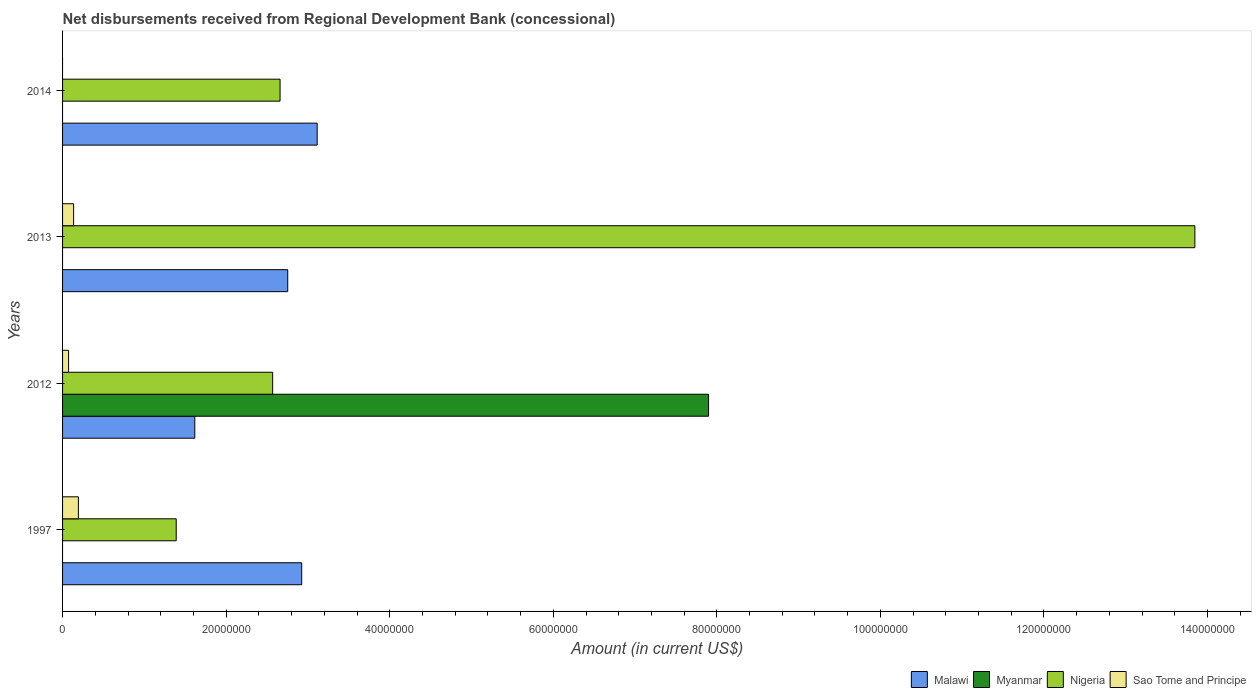How many different coloured bars are there?
Your answer should be very brief. 4. Are the number of bars per tick equal to the number of legend labels?
Provide a short and direct response. No. What is the amount of disbursements received from Regional Development Bank in Nigeria in 2012?
Give a very brief answer. 2.57e+07. Across all years, what is the maximum amount of disbursements received from Regional Development Bank in Sao Tome and Principe?
Offer a very short reply. 1.93e+06. In which year was the amount of disbursements received from Regional Development Bank in Malawi maximum?
Offer a very short reply. 2014. What is the total amount of disbursements received from Regional Development Bank in Sao Tome and Principe in the graph?
Offer a terse response. 4.02e+06. What is the difference between the amount of disbursements received from Regional Development Bank in Malawi in 2013 and that in 2014?
Your answer should be very brief. -3.60e+06. What is the difference between the amount of disbursements received from Regional Development Bank in Sao Tome and Principe in 2014 and the amount of disbursements received from Regional Development Bank in Malawi in 2012?
Keep it short and to the point. -1.62e+07. What is the average amount of disbursements received from Regional Development Bank in Myanmar per year?
Keep it short and to the point. 1.97e+07. In the year 2013, what is the difference between the amount of disbursements received from Regional Development Bank in Sao Tome and Principe and amount of disbursements received from Regional Development Bank in Malawi?
Provide a succinct answer. -2.62e+07. In how many years, is the amount of disbursements received from Regional Development Bank in Sao Tome and Principe greater than 108000000 US$?
Ensure brevity in your answer.  0. What is the ratio of the amount of disbursements received from Regional Development Bank in Malawi in 2013 to that in 2014?
Ensure brevity in your answer.  0.88. What is the difference between the highest and the second highest amount of disbursements received from Regional Development Bank in Nigeria?
Make the answer very short. 1.12e+08. What is the difference between the highest and the lowest amount of disbursements received from Regional Development Bank in Nigeria?
Your answer should be compact. 1.25e+08. In how many years, is the amount of disbursements received from Regional Development Bank in Sao Tome and Principe greater than the average amount of disbursements received from Regional Development Bank in Sao Tome and Principe taken over all years?
Offer a terse response. 2. Is the sum of the amount of disbursements received from Regional Development Bank in Malawi in 2012 and 2013 greater than the maximum amount of disbursements received from Regional Development Bank in Nigeria across all years?
Your answer should be compact. No. Is it the case that in every year, the sum of the amount of disbursements received from Regional Development Bank in Malawi and amount of disbursements received from Regional Development Bank in Nigeria is greater than the amount of disbursements received from Regional Development Bank in Sao Tome and Principe?
Offer a very short reply. Yes. How many bars are there?
Give a very brief answer. 12. How many years are there in the graph?
Provide a succinct answer. 4. Are the values on the major ticks of X-axis written in scientific E-notation?
Provide a short and direct response. No. Does the graph contain any zero values?
Provide a succinct answer. Yes. Where does the legend appear in the graph?
Offer a terse response. Bottom right. How are the legend labels stacked?
Make the answer very short. Horizontal. What is the title of the graph?
Ensure brevity in your answer.  Net disbursements received from Regional Development Bank (concessional). What is the Amount (in current US$) of Malawi in 1997?
Offer a very short reply. 2.92e+07. What is the Amount (in current US$) of Myanmar in 1997?
Make the answer very short. 0. What is the Amount (in current US$) in Nigeria in 1997?
Your response must be concise. 1.39e+07. What is the Amount (in current US$) in Sao Tome and Principe in 1997?
Keep it short and to the point. 1.93e+06. What is the Amount (in current US$) of Malawi in 2012?
Your answer should be compact. 1.62e+07. What is the Amount (in current US$) in Myanmar in 2012?
Your answer should be compact. 7.90e+07. What is the Amount (in current US$) in Nigeria in 2012?
Offer a terse response. 2.57e+07. What is the Amount (in current US$) in Sao Tome and Principe in 2012?
Provide a short and direct response. 7.36e+05. What is the Amount (in current US$) of Malawi in 2013?
Offer a very short reply. 2.75e+07. What is the Amount (in current US$) of Myanmar in 2013?
Provide a short and direct response. 0. What is the Amount (in current US$) in Nigeria in 2013?
Your answer should be compact. 1.38e+08. What is the Amount (in current US$) in Sao Tome and Principe in 2013?
Keep it short and to the point. 1.35e+06. What is the Amount (in current US$) of Malawi in 2014?
Keep it short and to the point. 3.11e+07. What is the Amount (in current US$) in Nigeria in 2014?
Offer a very short reply. 2.66e+07. What is the Amount (in current US$) of Sao Tome and Principe in 2014?
Your response must be concise. 0. Across all years, what is the maximum Amount (in current US$) of Malawi?
Your answer should be compact. 3.11e+07. Across all years, what is the maximum Amount (in current US$) in Myanmar?
Your answer should be compact. 7.90e+07. Across all years, what is the maximum Amount (in current US$) in Nigeria?
Your answer should be compact. 1.38e+08. Across all years, what is the maximum Amount (in current US$) of Sao Tome and Principe?
Give a very brief answer. 1.93e+06. Across all years, what is the minimum Amount (in current US$) of Malawi?
Keep it short and to the point. 1.62e+07. Across all years, what is the minimum Amount (in current US$) of Nigeria?
Offer a terse response. 1.39e+07. Across all years, what is the minimum Amount (in current US$) in Sao Tome and Principe?
Your answer should be very brief. 0. What is the total Amount (in current US$) of Malawi in the graph?
Offer a terse response. 1.04e+08. What is the total Amount (in current US$) of Myanmar in the graph?
Ensure brevity in your answer.  7.90e+07. What is the total Amount (in current US$) in Nigeria in the graph?
Keep it short and to the point. 2.05e+08. What is the total Amount (in current US$) of Sao Tome and Principe in the graph?
Your answer should be compact. 4.02e+06. What is the difference between the Amount (in current US$) of Malawi in 1997 and that in 2012?
Offer a terse response. 1.31e+07. What is the difference between the Amount (in current US$) in Nigeria in 1997 and that in 2012?
Make the answer very short. -1.18e+07. What is the difference between the Amount (in current US$) of Sao Tome and Principe in 1997 and that in 2012?
Provide a short and direct response. 1.20e+06. What is the difference between the Amount (in current US$) of Malawi in 1997 and that in 2013?
Offer a terse response. 1.71e+06. What is the difference between the Amount (in current US$) of Nigeria in 1997 and that in 2013?
Offer a terse response. -1.25e+08. What is the difference between the Amount (in current US$) in Sao Tome and Principe in 1997 and that in 2013?
Give a very brief answer. 5.84e+05. What is the difference between the Amount (in current US$) of Malawi in 1997 and that in 2014?
Give a very brief answer. -1.89e+06. What is the difference between the Amount (in current US$) in Nigeria in 1997 and that in 2014?
Offer a terse response. -1.27e+07. What is the difference between the Amount (in current US$) of Malawi in 2012 and that in 2013?
Provide a short and direct response. -1.14e+07. What is the difference between the Amount (in current US$) in Nigeria in 2012 and that in 2013?
Your answer should be very brief. -1.13e+08. What is the difference between the Amount (in current US$) of Sao Tome and Principe in 2012 and that in 2013?
Give a very brief answer. -6.14e+05. What is the difference between the Amount (in current US$) of Malawi in 2012 and that in 2014?
Offer a very short reply. -1.50e+07. What is the difference between the Amount (in current US$) of Nigeria in 2012 and that in 2014?
Give a very brief answer. -9.05e+05. What is the difference between the Amount (in current US$) of Malawi in 2013 and that in 2014?
Offer a very short reply. -3.60e+06. What is the difference between the Amount (in current US$) in Nigeria in 2013 and that in 2014?
Your answer should be very brief. 1.12e+08. What is the difference between the Amount (in current US$) of Malawi in 1997 and the Amount (in current US$) of Myanmar in 2012?
Keep it short and to the point. -4.97e+07. What is the difference between the Amount (in current US$) of Malawi in 1997 and the Amount (in current US$) of Nigeria in 2012?
Keep it short and to the point. 3.55e+06. What is the difference between the Amount (in current US$) of Malawi in 1997 and the Amount (in current US$) of Sao Tome and Principe in 2012?
Make the answer very short. 2.85e+07. What is the difference between the Amount (in current US$) of Nigeria in 1997 and the Amount (in current US$) of Sao Tome and Principe in 2012?
Provide a succinct answer. 1.32e+07. What is the difference between the Amount (in current US$) of Malawi in 1997 and the Amount (in current US$) of Nigeria in 2013?
Give a very brief answer. -1.09e+08. What is the difference between the Amount (in current US$) of Malawi in 1997 and the Amount (in current US$) of Sao Tome and Principe in 2013?
Your answer should be very brief. 2.79e+07. What is the difference between the Amount (in current US$) of Nigeria in 1997 and the Amount (in current US$) of Sao Tome and Principe in 2013?
Ensure brevity in your answer.  1.25e+07. What is the difference between the Amount (in current US$) of Malawi in 1997 and the Amount (in current US$) of Nigeria in 2014?
Your answer should be compact. 2.65e+06. What is the difference between the Amount (in current US$) in Malawi in 2012 and the Amount (in current US$) in Nigeria in 2013?
Your answer should be compact. -1.22e+08. What is the difference between the Amount (in current US$) of Malawi in 2012 and the Amount (in current US$) of Sao Tome and Principe in 2013?
Your answer should be very brief. 1.48e+07. What is the difference between the Amount (in current US$) in Myanmar in 2012 and the Amount (in current US$) in Nigeria in 2013?
Give a very brief answer. -5.95e+07. What is the difference between the Amount (in current US$) of Myanmar in 2012 and the Amount (in current US$) of Sao Tome and Principe in 2013?
Your response must be concise. 7.76e+07. What is the difference between the Amount (in current US$) of Nigeria in 2012 and the Amount (in current US$) of Sao Tome and Principe in 2013?
Keep it short and to the point. 2.43e+07. What is the difference between the Amount (in current US$) of Malawi in 2012 and the Amount (in current US$) of Nigeria in 2014?
Ensure brevity in your answer.  -1.04e+07. What is the difference between the Amount (in current US$) of Myanmar in 2012 and the Amount (in current US$) of Nigeria in 2014?
Keep it short and to the point. 5.24e+07. What is the difference between the Amount (in current US$) of Malawi in 2013 and the Amount (in current US$) of Nigeria in 2014?
Offer a terse response. 9.39e+05. What is the average Amount (in current US$) of Malawi per year?
Make the answer very short. 2.60e+07. What is the average Amount (in current US$) of Myanmar per year?
Your answer should be very brief. 1.97e+07. What is the average Amount (in current US$) in Nigeria per year?
Offer a very short reply. 5.12e+07. What is the average Amount (in current US$) of Sao Tome and Principe per year?
Provide a short and direct response. 1.00e+06. In the year 1997, what is the difference between the Amount (in current US$) in Malawi and Amount (in current US$) in Nigeria?
Make the answer very short. 1.53e+07. In the year 1997, what is the difference between the Amount (in current US$) of Malawi and Amount (in current US$) of Sao Tome and Principe?
Your response must be concise. 2.73e+07. In the year 1997, what is the difference between the Amount (in current US$) of Nigeria and Amount (in current US$) of Sao Tome and Principe?
Offer a terse response. 1.20e+07. In the year 2012, what is the difference between the Amount (in current US$) in Malawi and Amount (in current US$) in Myanmar?
Keep it short and to the point. -6.28e+07. In the year 2012, what is the difference between the Amount (in current US$) of Malawi and Amount (in current US$) of Nigeria?
Provide a succinct answer. -9.52e+06. In the year 2012, what is the difference between the Amount (in current US$) of Malawi and Amount (in current US$) of Sao Tome and Principe?
Provide a short and direct response. 1.54e+07. In the year 2012, what is the difference between the Amount (in current US$) of Myanmar and Amount (in current US$) of Nigeria?
Keep it short and to the point. 5.33e+07. In the year 2012, what is the difference between the Amount (in current US$) of Myanmar and Amount (in current US$) of Sao Tome and Principe?
Ensure brevity in your answer.  7.82e+07. In the year 2012, what is the difference between the Amount (in current US$) in Nigeria and Amount (in current US$) in Sao Tome and Principe?
Provide a short and direct response. 2.50e+07. In the year 2013, what is the difference between the Amount (in current US$) of Malawi and Amount (in current US$) of Nigeria?
Provide a short and direct response. -1.11e+08. In the year 2013, what is the difference between the Amount (in current US$) of Malawi and Amount (in current US$) of Sao Tome and Principe?
Your answer should be very brief. 2.62e+07. In the year 2013, what is the difference between the Amount (in current US$) in Nigeria and Amount (in current US$) in Sao Tome and Principe?
Your answer should be compact. 1.37e+08. In the year 2014, what is the difference between the Amount (in current US$) in Malawi and Amount (in current US$) in Nigeria?
Keep it short and to the point. 4.54e+06. What is the ratio of the Amount (in current US$) in Malawi in 1997 to that in 2012?
Your answer should be very brief. 1.81. What is the ratio of the Amount (in current US$) in Nigeria in 1997 to that in 2012?
Offer a very short reply. 0.54. What is the ratio of the Amount (in current US$) of Sao Tome and Principe in 1997 to that in 2012?
Provide a succinct answer. 2.63. What is the ratio of the Amount (in current US$) in Malawi in 1997 to that in 2013?
Ensure brevity in your answer.  1.06. What is the ratio of the Amount (in current US$) in Nigeria in 1997 to that in 2013?
Your answer should be very brief. 0.1. What is the ratio of the Amount (in current US$) in Sao Tome and Principe in 1997 to that in 2013?
Offer a very short reply. 1.43. What is the ratio of the Amount (in current US$) of Malawi in 1997 to that in 2014?
Ensure brevity in your answer.  0.94. What is the ratio of the Amount (in current US$) in Nigeria in 1997 to that in 2014?
Give a very brief answer. 0.52. What is the ratio of the Amount (in current US$) in Malawi in 2012 to that in 2013?
Keep it short and to the point. 0.59. What is the ratio of the Amount (in current US$) in Nigeria in 2012 to that in 2013?
Ensure brevity in your answer.  0.19. What is the ratio of the Amount (in current US$) of Sao Tome and Principe in 2012 to that in 2013?
Give a very brief answer. 0.55. What is the ratio of the Amount (in current US$) in Malawi in 2012 to that in 2014?
Your answer should be compact. 0.52. What is the ratio of the Amount (in current US$) of Malawi in 2013 to that in 2014?
Keep it short and to the point. 0.88. What is the ratio of the Amount (in current US$) in Nigeria in 2013 to that in 2014?
Provide a succinct answer. 5.21. What is the difference between the highest and the second highest Amount (in current US$) in Malawi?
Ensure brevity in your answer.  1.89e+06. What is the difference between the highest and the second highest Amount (in current US$) of Nigeria?
Offer a very short reply. 1.12e+08. What is the difference between the highest and the second highest Amount (in current US$) in Sao Tome and Principe?
Give a very brief answer. 5.84e+05. What is the difference between the highest and the lowest Amount (in current US$) of Malawi?
Give a very brief answer. 1.50e+07. What is the difference between the highest and the lowest Amount (in current US$) of Myanmar?
Provide a succinct answer. 7.90e+07. What is the difference between the highest and the lowest Amount (in current US$) of Nigeria?
Provide a succinct answer. 1.25e+08. What is the difference between the highest and the lowest Amount (in current US$) of Sao Tome and Principe?
Give a very brief answer. 1.93e+06. 